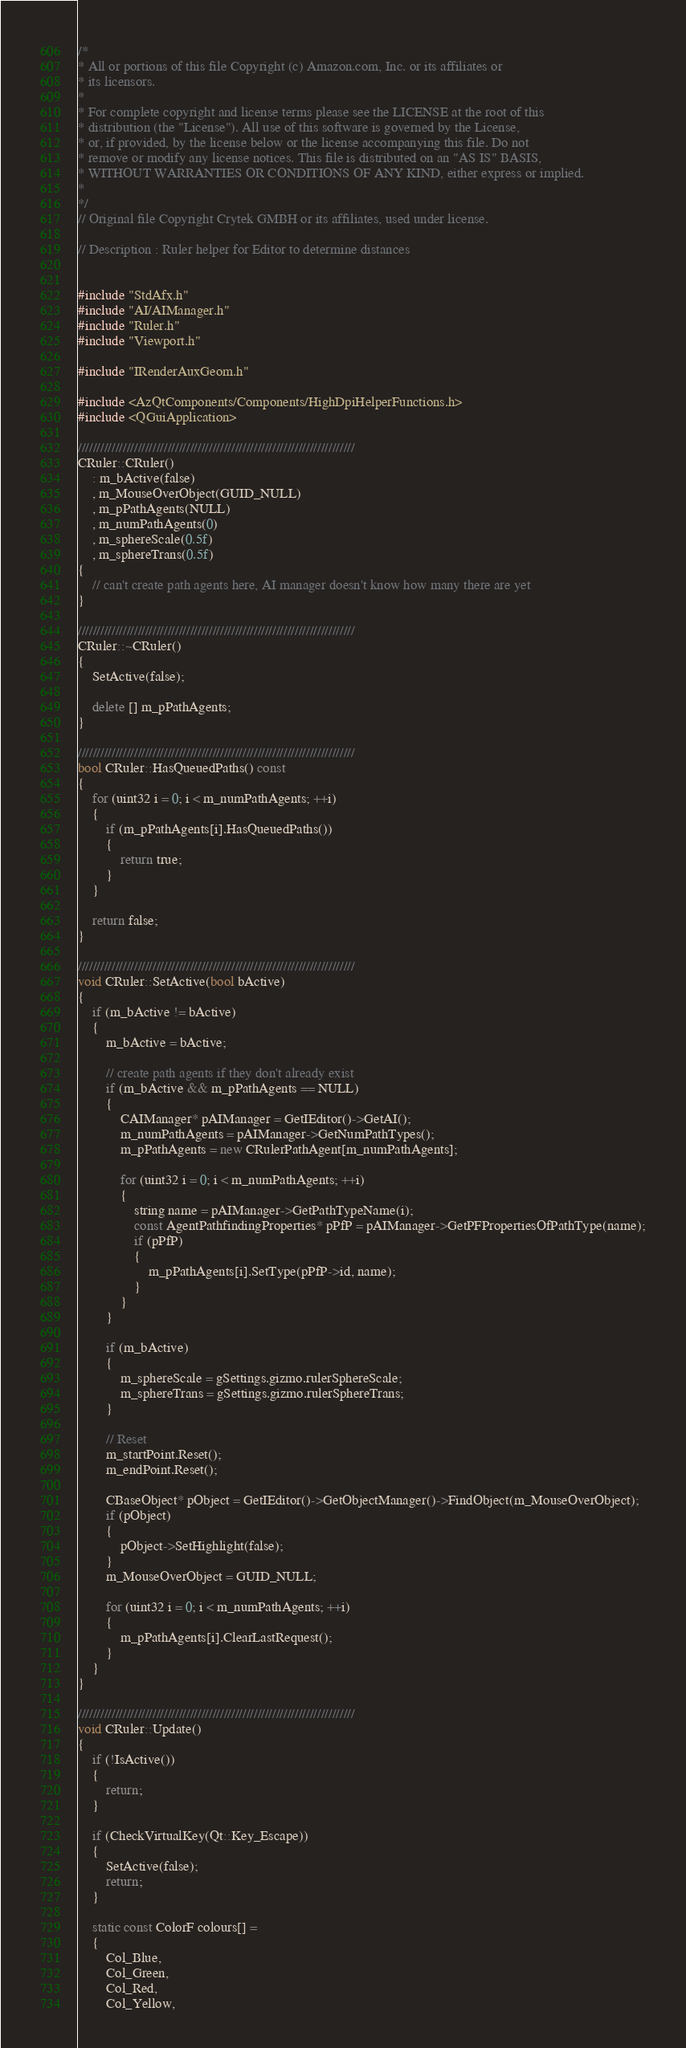Convert code to text. <code><loc_0><loc_0><loc_500><loc_500><_C++_>/*
* All or portions of this file Copyright (c) Amazon.com, Inc. or its affiliates or
* its licensors.
*
* For complete copyright and license terms please see the LICENSE at the root of this
* distribution (the "License"). All use of this software is governed by the License,
* or, if provided, by the license below or the license accompanying this file. Do not
* remove or modify any license notices. This file is distributed on an "AS IS" BASIS,
* WITHOUT WARRANTIES OR CONDITIONS OF ANY KIND, either express or implied.
*
*/
// Original file Copyright Crytek GMBH or its affiliates, used under license.

// Description : Ruler helper for Editor to determine distances


#include "StdAfx.h"
#include "AI/AIManager.h"
#include "Ruler.h"
#include "Viewport.h"

#include "IRenderAuxGeom.h"

#include <AzQtComponents/Components/HighDpiHelperFunctions.h>
#include <QGuiApplication>

//////////////////////////////////////////////////////////////////////////
CRuler::CRuler()
    : m_bActive(false)
    , m_MouseOverObject(GUID_NULL)
    , m_pPathAgents(NULL)
    , m_numPathAgents(0)
    , m_sphereScale(0.5f)
    , m_sphereTrans(0.5f)
{
    // can't create path agents here, AI manager doesn't know how many there are yet
}

//////////////////////////////////////////////////////////////////////////
CRuler::~CRuler()
{
    SetActive(false);

    delete [] m_pPathAgents;
}

//////////////////////////////////////////////////////////////////////////
bool CRuler::HasQueuedPaths() const
{
    for (uint32 i = 0; i < m_numPathAgents; ++i)
    {
        if (m_pPathAgents[i].HasQueuedPaths())
        {
            return true;
        }
    }

    return false;
}

//////////////////////////////////////////////////////////////////////////
void CRuler::SetActive(bool bActive)
{
    if (m_bActive != bActive)
    {
        m_bActive = bActive;

        // create path agents if they don't already exist
        if (m_bActive && m_pPathAgents == NULL)
        {
            CAIManager* pAIManager = GetIEditor()->GetAI();
            m_numPathAgents = pAIManager->GetNumPathTypes();
            m_pPathAgents = new CRulerPathAgent[m_numPathAgents];

            for (uint32 i = 0; i < m_numPathAgents; ++i)
            {
                string name = pAIManager->GetPathTypeName(i);
                const AgentPathfindingProperties* pPfP = pAIManager->GetPFPropertiesOfPathType(name);
                if (pPfP)
                {
                    m_pPathAgents[i].SetType(pPfP->id, name);
                }
            }
        }

        if (m_bActive)
        {
            m_sphereScale = gSettings.gizmo.rulerSphereScale;
            m_sphereTrans = gSettings.gizmo.rulerSphereTrans;
        }

        // Reset
        m_startPoint.Reset();
        m_endPoint.Reset();

        CBaseObject* pObject = GetIEditor()->GetObjectManager()->FindObject(m_MouseOverObject);
        if (pObject)
        {
            pObject->SetHighlight(false);
        }
        m_MouseOverObject = GUID_NULL;

        for (uint32 i = 0; i < m_numPathAgents; ++i)
        {
            m_pPathAgents[i].ClearLastRequest();
        }
    }
}

//////////////////////////////////////////////////////////////////////////
void CRuler::Update()
{
    if (!IsActive())
    {
        return;
    }

    if (CheckVirtualKey(Qt::Key_Escape))
    {
        SetActive(false);
        return;
    }

    static const ColorF colours[] =
    {
        Col_Blue,
        Col_Green,
        Col_Red,
        Col_Yellow,</code> 